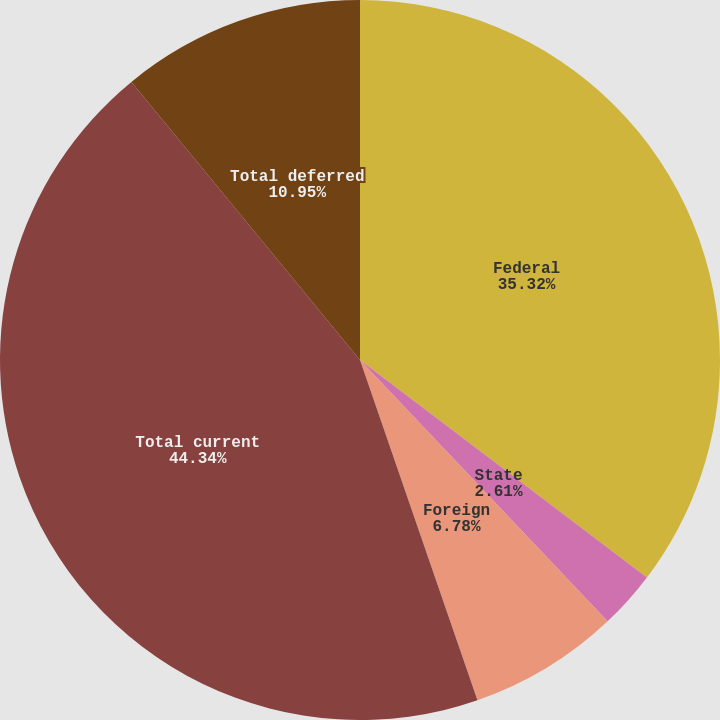Convert chart to OTSL. <chart><loc_0><loc_0><loc_500><loc_500><pie_chart><fcel>Federal<fcel>State<fcel>Foreign<fcel>Total current<fcel>Total deferred<nl><fcel>35.32%<fcel>2.61%<fcel>6.78%<fcel>44.34%<fcel>10.95%<nl></chart> 